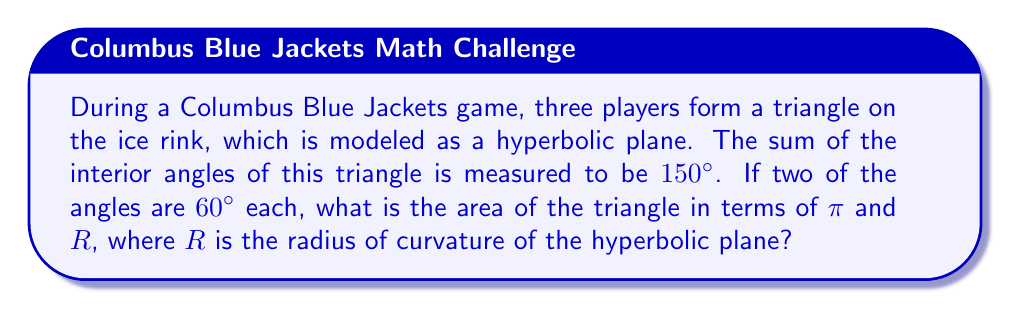Teach me how to tackle this problem. Let's approach this step-by-step:

1) In hyperbolic geometry, the sum of the angles in a triangle is less than 180°. The difference between 180° and the actual sum is called the defect.

2) Defect = 180° - (sum of angles)
   $$ \text{Defect} = 180^\circ - 150^\circ = 30^\circ $$

3) In hyperbolic geometry, the area of a triangle is directly related to its defect by the formula:
   $$ \text{Area} = (\text{Defect in radians}) \cdot R^2 $$
   where R is the radius of curvature of the hyperbolic plane.

4) We need to convert the defect from degrees to radians:
   $$ 30^\circ \cdot \frac{\pi}{180^\circ} = \frac{\pi}{6} \text{ radians} $$

5) Now we can calculate the area:
   $$ \text{Area} = \frac{\pi}{6} \cdot R^2 $$

6) This can be simplified to:
   $$ \text{Area} = \frac{\pi R^2}{6} $$

Thus, the area of the triangle formed by the three players on the hyperbolic ice rink is $\frac{\pi R^2}{6}$.
Answer: $\frac{\pi R^2}{6}$ 